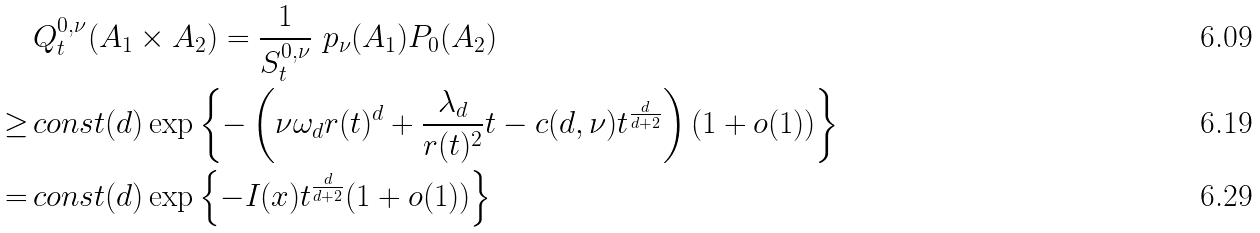Convert formula to latex. <formula><loc_0><loc_0><loc_500><loc_500>& Q _ { t } ^ { 0 , \nu } ( A _ { 1 } \times A _ { 2 } ) = \frac { 1 } { S _ { t } ^ { 0 , \nu } } \ p _ { \nu } ( A _ { 1 } ) P _ { 0 } ( A _ { 2 } ) \\ \geq \, & c o n s t ( d ) \exp \left \{ - \left ( \nu \omega _ { d } r ( t ) ^ { d } + \frac { \lambda _ { d } } { r ( t ) ^ { 2 } } t - c ( d , \nu ) t ^ { \frac { d } { d + 2 } } \right ) ( 1 + o ( 1 ) ) \right \} \\ = \, & c o n s t ( d ) \exp \left \{ - I ( x ) t ^ { \frac { d } { d + 2 } } ( 1 + o ( 1 ) ) \right \}</formula> 